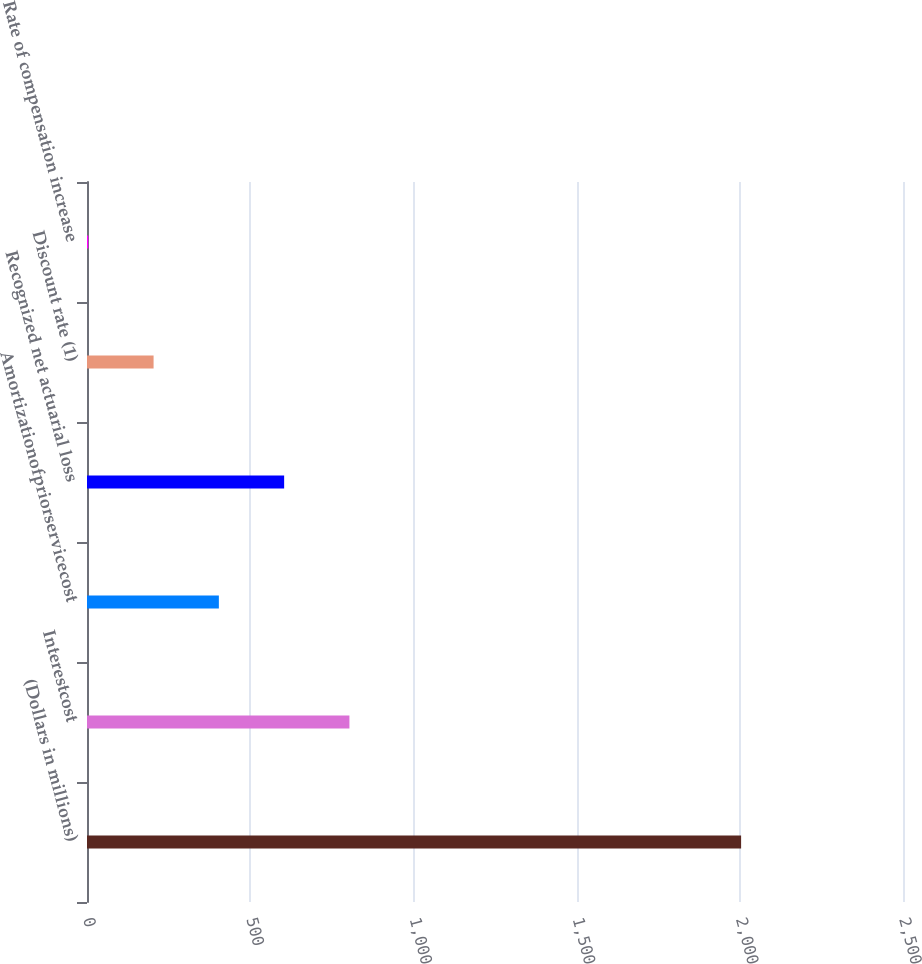Convert chart to OTSL. <chart><loc_0><loc_0><loc_500><loc_500><bar_chart><fcel>(Dollars in millions)<fcel>Interestcost<fcel>Amortizationofpriorservicecost<fcel>Recognized net actuarial loss<fcel>Discount rate (1)<fcel>Rate of compensation increase<nl><fcel>2004<fcel>804<fcel>404<fcel>604<fcel>204<fcel>4<nl></chart> 